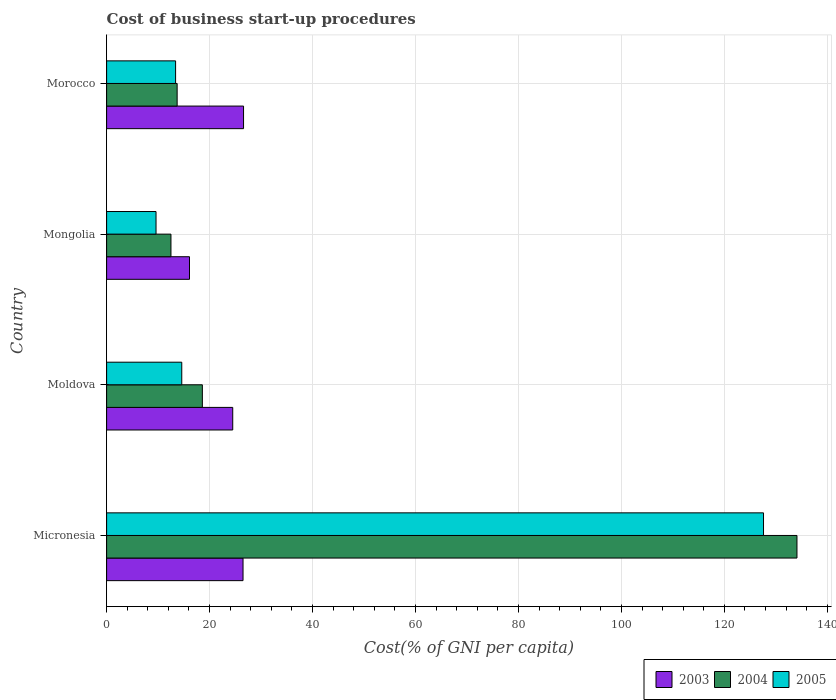How many different coloured bars are there?
Keep it short and to the point. 3. How many groups of bars are there?
Provide a succinct answer. 4. Are the number of bars per tick equal to the number of legend labels?
Keep it short and to the point. Yes. Are the number of bars on each tick of the Y-axis equal?
Your answer should be very brief. Yes. How many bars are there on the 1st tick from the top?
Give a very brief answer. 3. How many bars are there on the 4th tick from the bottom?
Offer a terse response. 3. What is the label of the 2nd group of bars from the top?
Make the answer very short. Mongolia. What is the cost of business start-up procedures in 2004 in Mongolia?
Ensure brevity in your answer.  12.5. Across all countries, what is the maximum cost of business start-up procedures in 2004?
Provide a succinct answer. 134.1. Across all countries, what is the minimum cost of business start-up procedures in 2005?
Your answer should be compact. 9.6. In which country was the cost of business start-up procedures in 2003 maximum?
Keep it short and to the point. Morocco. In which country was the cost of business start-up procedures in 2003 minimum?
Give a very brief answer. Mongolia. What is the total cost of business start-up procedures in 2004 in the graph?
Keep it short and to the point. 178.9. What is the difference between the cost of business start-up procedures in 2005 in Micronesia and that in Morocco?
Provide a short and direct response. 114.2. What is the difference between the cost of business start-up procedures in 2003 in Mongolia and the cost of business start-up procedures in 2005 in Micronesia?
Provide a short and direct response. -111.5. What is the average cost of business start-up procedures in 2005 per country?
Provide a short and direct response. 41.3. What is the difference between the cost of business start-up procedures in 2003 and cost of business start-up procedures in 2004 in Morocco?
Ensure brevity in your answer.  12.9. What is the ratio of the cost of business start-up procedures in 2005 in Micronesia to that in Morocco?
Offer a terse response. 9.52. Is the cost of business start-up procedures in 2005 in Moldova less than that in Mongolia?
Your response must be concise. No. Is the difference between the cost of business start-up procedures in 2003 in Moldova and Mongolia greater than the difference between the cost of business start-up procedures in 2004 in Moldova and Mongolia?
Offer a terse response. Yes. What is the difference between the highest and the second highest cost of business start-up procedures in 2003?
Make the answer very short. 0.1. What is the difference between the highest and the lowest cost of business start-up procedures in 2004?
Provide a succinct answer. 121.6. What does the 1st bar from the top in Morocco represents?
Offer a very short reply. 2005. Does the graph contain any zero values?
Keep it short and to the point. No. Does the graph contain grids?
Ensure brevity in your answer.  Yes. Where does the legend appear in the graph?
Make the answer very short. Bottom right. How are the legend labels stacked?
Provide a short and direct response. Horizontal. What is the title of the graph?
Provide a short and direct response. Cost of business start-up procedures. Does "2005" appear as one of the legend labels in the graph?
Keep it short and to the point. Yes. What is the label or title of the X-axis?
Make the answer very short. Cost(% of GNI per capita). What is the label or title of the Y-axis?
Make the answer very short. Country. What is the Cost(% of GNI per capita) of 2003 in Micronesia?
Provide a short and direct response. 26.5. What is the Cost(% of GNI per capita) of 2004 in Micronesia?
Your response must be concise. 134.1. What is the Cost(% of GNI per capita) of 2005 in Micronesia?
Your answer should be very brief. 127.6. What is the Cost(% of GNI per capita) of 2003 in Moldova?
Give a very brief answer. 24.5. What is the Cost(% of GNI per capita) in 2004 in Mongolia?
Offer a terse response. 12.5. What is the Cost(% of GNI per capita) of 2003 in Morocco?
Keep it short and to the point. 26.6. What is the Cost(% of GNI per capita) in 2004 in Morocco?
Offer a very short reply. 13.7. What is the Cost(% of GNI per capita) in 2005 in Morocco?
Offer a terse response. 13.4. Across all countries, what is the maximum Cost(% of GNI per capita) of 2003?
Provide a succinct answer. 26.6. Across all countries, what is the maximum Cost(% of GNI per capita) of 2004?
Your answer should be very brief. 134.1. Across all countries, what is the maximum Cost(% of GNI per capita) of 2005?
Give a very brief answer. 127.6. Across all countries, what is the minimum Cost(% of GNI per capita) in 2003?
Give a very brief answer. 16.1. Across all countries, what is the minimum Cost(% of GNI per capita) of 2005?
Your response must be concise. 9.6. What is the total Cost(% of GNI per capita) in 2003 in the graph?
Offer a very short reply. 93.7. What is the total Cost(% of GNI per capita) of 2004 in the graph?
Offer a terse response. 178.9. What is the total Cost(% of GNI per capita) in 2005 in the graph?
Provide a succinct answer. 165.2. What is the difference between the Cost(% of GNI per capita) in 2003 in Micronesia and that in Moldova?
Your answer should be compact. 2. What is the difference between the Cost(% of GNI per capita) in 2004 in Micronesia and that in Moldova?
Offer a very short reply. 115.5. What is the difference between the Cost(% of GNI per capita) of 2005 in Micronesia and that in Moldova?
Keep it short and to the point. 113. What is the difference between the Cost(% of GNI per capita) of 2004 in Micronesia and that in Mongolia?
Offer a very short reply. 121.6. What is the difference between the Cost(% of GNI per capita) of 2005 in Micronesia and that in Mongolia?
Ensure brevity in your answer.  118. What is the difference between the Cost(% of GNI per capita) of 2003 in Micronesia and that in Morocco?
Give a very brief answer. -0.1. What is the difference between the Cost(% of GNI per capita) in 2004 in Micronesia and that in Morocco?
Offer a very short reply. 120.4. What is the difference between the Cost(% of GNI per capita) in 2005 in Micronesia and that in Morocco?
Provide a succinct answer. 114.2. What is the difference between the Cost(% of GNI per capita) of 2004 in Moldova and that in Mongolia?
Your response must be concise. 6.1. What is the difference between the Cost(% of GNI per capita) in 2003 in Moldova and that in Morocco?
Your answer should be compact. -2.1. What is the difference between the Cost(% of GNI per capita) in 2004 in Mongolia and that in Morocco?
Keep it short and to the point. -1.2. What is the difference between the Cost(% of GNI per capita) in 2005 in Mongolia and that in Morocco?
Provide a succinct answer. -3.8. What is the difference between the Cost(% of GNI per capita) of 2004 in Micronesia and the Cost(% of GNI per capita) of 2005 in Moldova?
Give a very brief answer. 119.5. What is the difference between the Cost(% of GNI per capita) in 2003 in Micronesia and the Cost(% of GNI per capita) in 2005 in Mongolia?
Give a very brief answer. 16.9. What is the difference between the Cost(% of GNI per capita) in 2004 in Micronesia and the Cost(% of GNI per capita) in 2005 in Mongolia?
Ensure brevity in your answer.  124.5. What is the difference between the Cost(% of GNI per capita) of 2003 in Micronesia and the Cost(% of GNI per capita) of 2004 in Morocco?
Give a very brief answer. 12.8. What is the difference between the Cost(% of GNI per capita) of 2004 in Micronesia and the Cost(% of GNI per capita) of 2005 in Morocco?
Your answer should be compact. 120.7. What is the difference between the Cost(% of GNI per capita) in 2004 in Moldova and the Cost(% of GNI per capita) in 2005 in Mongolia?
Keep it short and to the point. 9. What is the difference between the Cost(% of GNI per capita) in 2003 in Moldova and the Cost(% of GNI per capita) in 2005 in Morocco?
Keep it short and to the point. 11.1. What is the difference between the Cost(% of GNI per capita) of 2004 in Moldova and the Cost(% of GNI per capita) of 2005 in Morocco?
Provide a succinct answer. 5.2. What is the difference between the Cost(% of GNI per capita) of 2003 in Mongolia and the Cost(% of GNI per capita) of 2004 in Morocco?
Keep it short and to the point. 2.4. What is the difference between the Cost(% of GNI per capita) in 2004 in Mongolia and the Cost(% of GNI per capita) in 2005 in Morocco?
Make the answer very short. -0.9. What is the average Cost(% of GNI per capita) in 2003 per country?
Offer a very short reply. 23.43. What is the average Cost(% of GNI per capita) of 2004 per country?
Make the answer very short. 44.73. What is the average Cost(% of GNI per capita) in 2005 per country?
Your answer should be very brief. 41.3. What is the difference between the Cost(% of GNI per capita) in 2003 and Cost(% of GNI per capita) in 2004 in Micronesia?
Ensure brevity in your answer.  -107.6. What is the difference between the Cost(% of GNI per capita) of 2003 and Cost(% of GNI per capita) of 2005 in Micronesia?
Provide a short and direct response. -101.1. What is the difference between the Cost(% of GNI per capita) of 2004 and Cost(% of GNI per capita) of 2005 in Micronesia?
Give a very brief answer. 6.5. What is the difference between the Cost(% of GNI per capita) of 2003 and Cost(% of GNI per capita) of 2005 in Moldova?
Your answer should be compact. 9.9. What is the difference between the Cost(% of GNI per capita) of 2004 and Cost(% of GNI per capita) of 2005 in Moldova?
Offer a terse response. 4. What is the difference between the Cost(% of GNI per capita) in 2003 and Cost(% of GNI per capita) in 2004 in Morocco?
Your answer should be compact. 12.9. What is the ratio of the Cost(% of GNI per capita) in 2003 in Micronesia to that in Moldova?
Your answer should be compact. 1.08. What is the ratio of the Cost(% of GNI per capita) of 2004 in Micronesia to that in Moldova?
Your answer should be very brief. 7.21. What is the ratio of the Cost(% of GNI per capita) in 2005 in Micronesia to that in Moldova?
Provide a short and direct response. 8.74. What is the ratio of the Cost(% of GNI per capita) of 2003 in Micronesia to that in Mongolia?
Provide a short and direct response. 1.65. What is the ratio of the Cost(% of GNI per capita) of 2004 in Micronesia to that in Mongolia?
Offer a terse response. 10.73. What is the ratio of the Cost(% of GNI per capita) of 2005 in Micronesia to that in Mongolia?
Your response must be concise. 13.29. What is the ratio of the Cost(% of GNI per capita) in 2003 in Micronesia to that in Morocco?
Your response must be concise. 1. What is the ratio of the Cost(% of GNI per capita) of 2004 in Micronesia to that in Morocco?
Offer a terse response. 9.79. What is the ratio of the Cost(% of GNI per capita) of 2005 in Micronesia to that in Morocco?
Your response must be concise. 9.52. What is the ratio of the Cost(% of GNI per capita) in 2003 in Moldova to that in Mongolia?
Offer a very short reply. 1.52. What is the ratio of the Cost(% of GNI per capita) in 2004 in Moldova to that in Mongolia?
Keep it short and to the point. 1.49. What is the ratio of the Cost(% of GNI per capita) of 2005 in Moldova to that in Mongolia?
Give a very brief answer. 1.52. What is the ratio of the Cost(% of GNI per capita) of 2003 in Moldova to that in Morocco?
Offer a terse response. 0.92. What is the ratio of the Cost(% of GNI per capita) in 2004 in Moldova to that in Morocco?
Your answer should be very brief. 1.36. What is the ratio of the Cost(% of GNI per capita) of 2005 in Moldova to that in Morocco?
Your answer should be very brief. 1.09. What is the ratio of the Cost(% of GNI per capita) of 2003 in Mongolia to that in Morocco?
Keep it short and to the point. 0.61. What is the ratio of the Cost(% of GNI per capita) in 2004 in Mongolia to that in Morocco?
Offer a very short reply. 0.91. What is the ratio of the Cost(% of GNI per capita) of 2005 in Mongolia to that in Morocco?
Ensure brevity in your answer.  0.72. What is the difference between the highest and the second highest Cost(% of GNI per capita) of 2003?
Keep it short and to the point. 0.1. What is the difference between the highest and the second highest Cost(% of GNI per capita) of 2004?
Provide a short and direct response. 115.5. What is the difference between the highest and the second highest Cost(% of GNI per capita) in 2005?
Give a very brief answer. 113. What is the difference between the highest and the lowest Cost(% of GNI per capita) in 2004?
Provide a short and direct response. 121.6. What is the difference between the highest and the lowest Cost(% of GNI per capita) in 2005?
Provide a succinct answer. 118. 